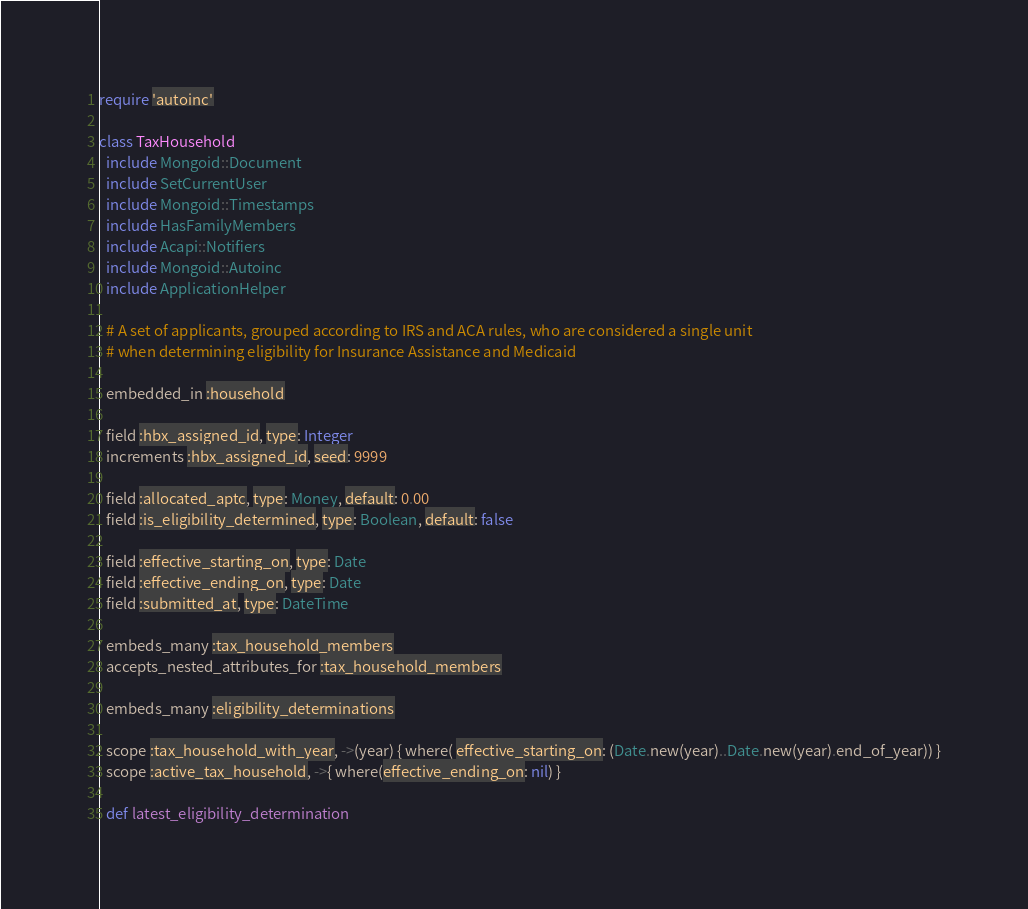<code> <loc_0><loc_0><loc_500><loc_500><_Ruby_>require 'autoinc'

class TaxHousehold
  include Mongoid::Document
  include SetCurrentUser
  include Mongoid::Timestamps
  include HasFamilyMembers
  include Acapi::Notifiers
  include Mongoid::Autoinc
  include ApplicationHelper

  # A set of applicants, grouped according to IRS and ACA rules, who are considered a single unit
  # when determining eligibility for Insurance Assistance and Medicaid

  embedded_in :household

  field :hbx_assigned_id, type: Integer
  increments :hbx_assigned_id, seed: 9999

  field :allocated_aptc, type: Money, default: 0.00
  field :is_eligibility_determined, type: Boolean, default: false

  field :effective_starting_on, type: Date
  field :effective_ending_on, type: Date
  field :submitted_at, type: DateTime

  embeds_many :tax_household_members
  accepts_nested_attributes_for :tax_household_members

  embeds_many :eligibility_determinations

  scope :tax_household_with_year, ->(year) { where( effective_starting_on: (Date.new(year)..Date.new(year).end_of_year)) }
  scope :active_tax_household, ->{ where(effective_ending_on: nil) }

  def latest_eligibility_determination</code> 